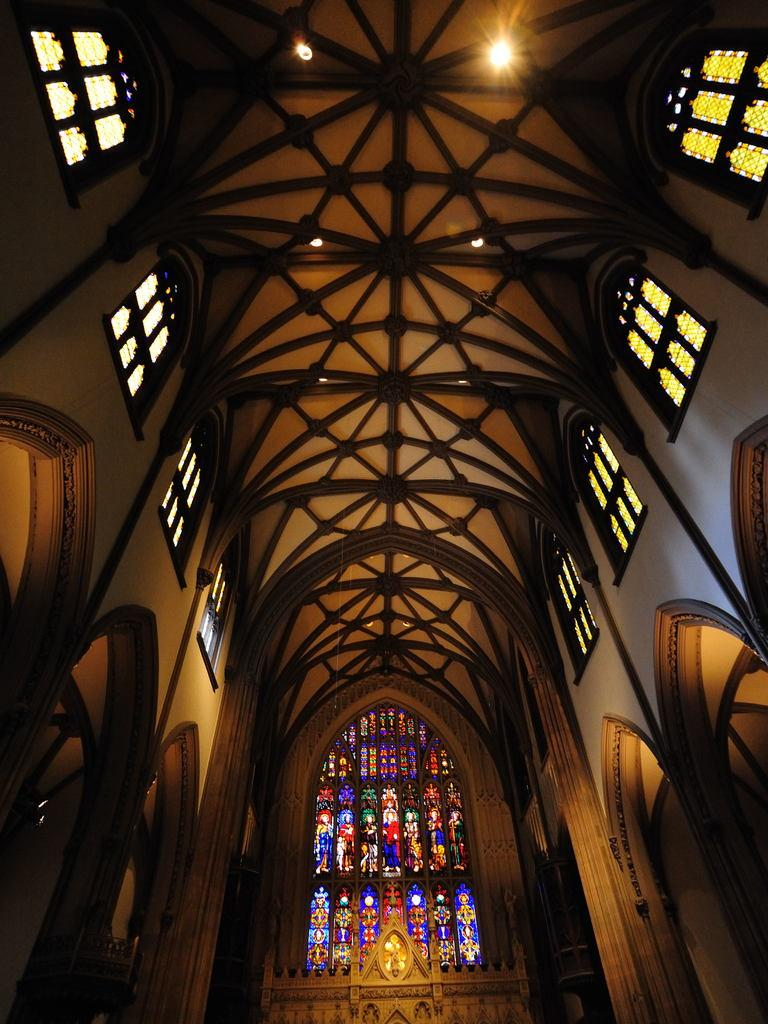What type of view is shown in the image? The image is an inside view of a building. What architectural features can be seen in the image? There are windows and walls visible in the image. What type of lighting is present in the image? There are lights on the ceiling in the image. What design elements can be seen on specific objects in the image? There are designs on the glasses in the image. Can you describe any other objects present in the image? Other objects are present in the image, but their specific details are not mentioned in the provided facts. facts. How long does it take for the minute to pass in the image? The concept of time passing is not visible or measurable in the image, as it is a still photograph. 